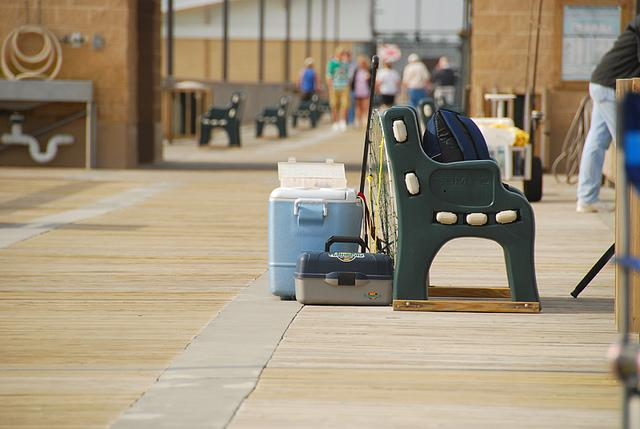What will the person who left this gear do with it? Please explain your reasoning. go fishing. There is a long stick. 